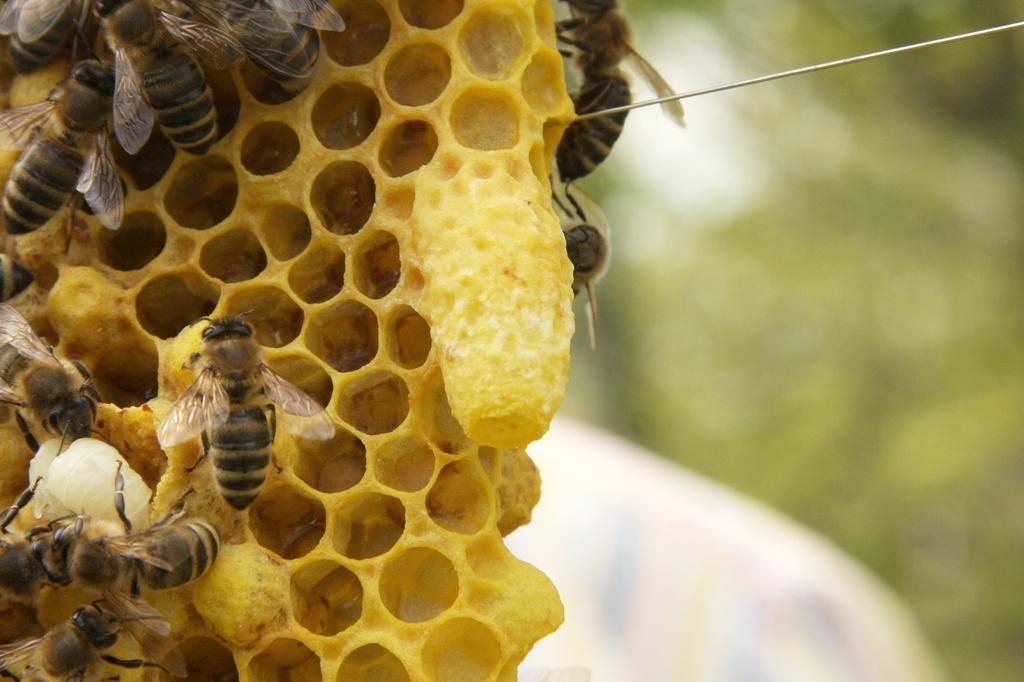Please provide a concise description of this image. In this image in the front there are honey bees and there is an object which is yellow in colour and the background is blurry. 